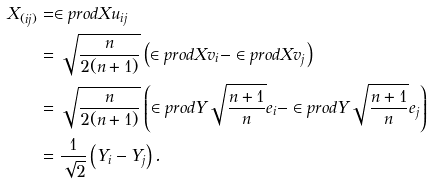<formula> <loc_0><loc_0><loc_500><loc_500>X _ { ( i j ) } & = \in p r o d { X } { u _ { i j } } \\ & = \sqrt { \frac { n } { 2 ( n + 1 ) } } \left ( \in p r o d { X } { v _ { i } } - \in p r o d { X } { v _ { j } } \right ) \\ & = \sqrt { \frac { n } { 2 ( n + 1 ) } } \left ( \in p r o d { Y } { \sqrt { \frac { n + 1 } { n } } e _ { i } } - \in p r o d { Y } { \sqrt { \frac { n + 1 } { n } } e _ { j } } \right ) \\ & = \frac { 1 } { \sqrt { 2 } } \left ( Y _ { i } - Y _ { j } \right ) .</formula> 